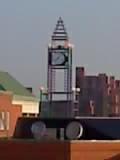How many zebras are standing up?
Give a very brief answer. 0. 